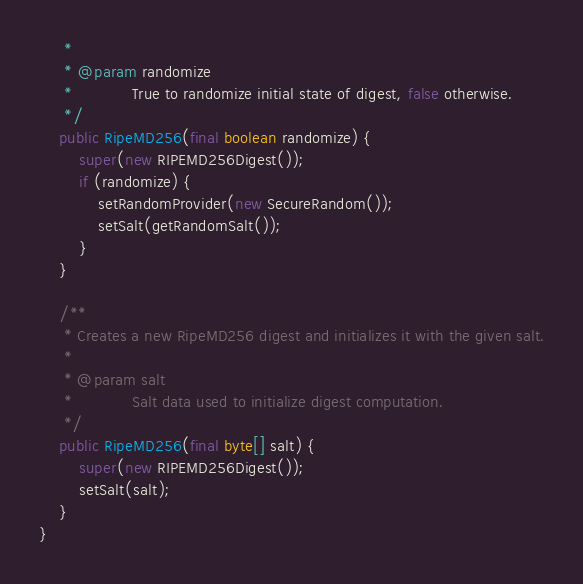<code> <loc_0><loc_0><loc_500><loc_500><_Java_>	 *
	 * @param randomize
	 *            True to randomize initial state of digest, false otherwise.
	 */
	public RipeMD256(final boolean randomize) {
		super(new RIPEMD256Digest());
		if (randomize) {
			setRandomProvider(new SecureRandom());
			setSalt(getRandomSalt());
		}
	}

	/**
	 * Creates a new RipeMD256 digest and initializes it with the given salt.
	 *
	 * @param salt
	 *            Salt data used to initialize digest computation.
	 */
	public RipeMD256(final byte[] salt) {
		super(new RIPEMD256Digest());
		setSalt(salt);
	}
}</code> 